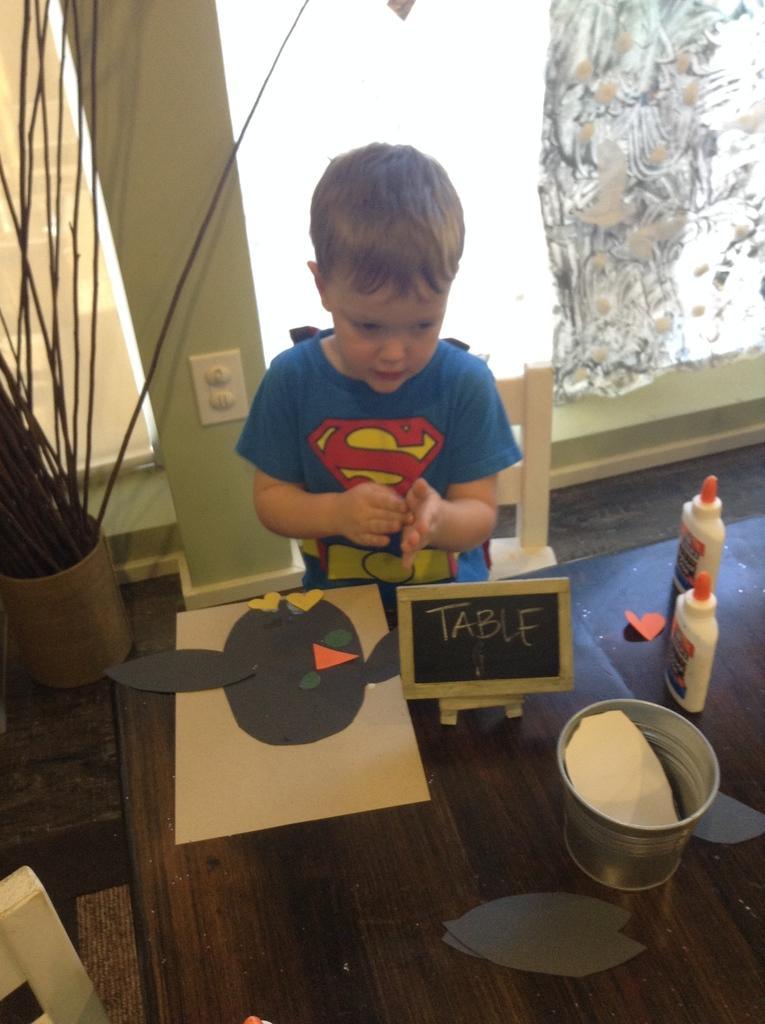Please provide a concise description of this image. Here there is a boy at the table. On the table we can see papers,bottles,small black board and a small bucket. In the background there are chairs,houseplant in a pot,wall,curtain and this is floor. 